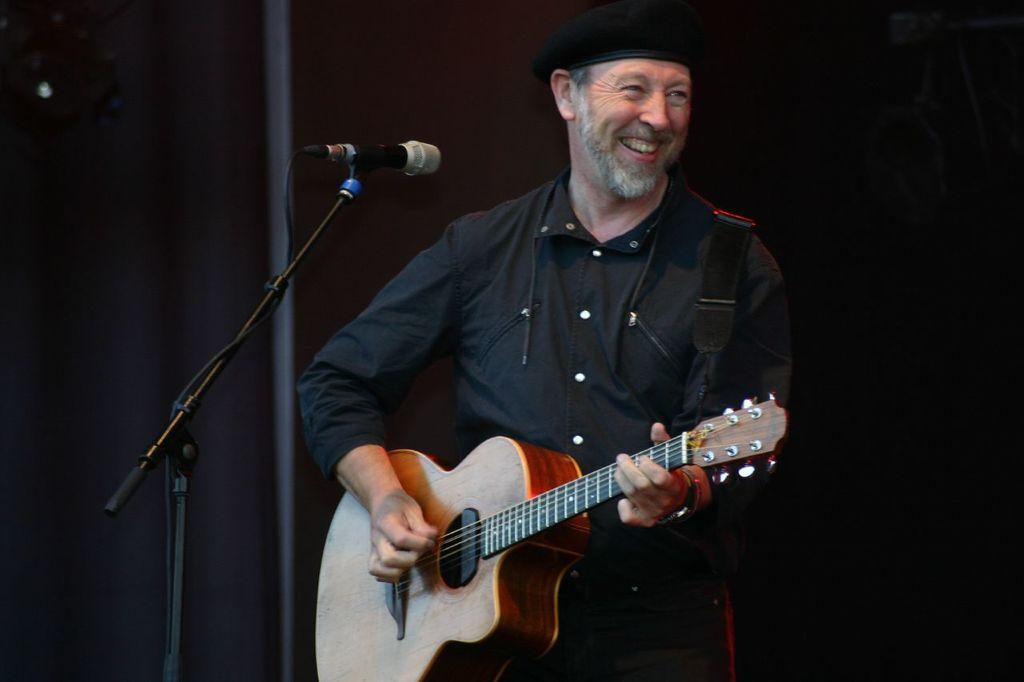What is the main subject of the image? There is a man in the image. What is the man doing in the image? The man is laughing. What object is the man holding in the image? The man is holding a guitar. What can be seen on the left side of the image? There is a microphone on the left side of the image. How many bikes are parked next to the man in the image? There are no bikes present in the image. What does the man's mom think about his performance in the image? There is no information about the man's mom in the image, so we cannot determine her thoughts. 